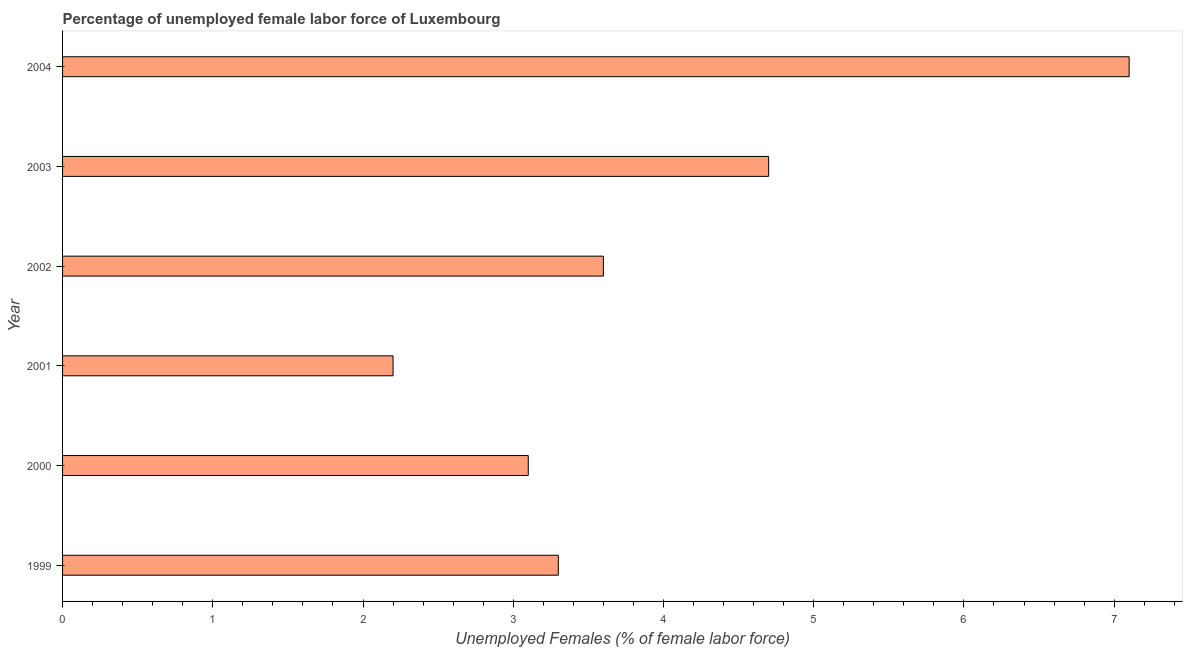Does the graph contain any zero values?
Provide a succinct answer. No. Does the graph contain grids?
Your response must be concise. No. What is the title of the graph?
Your answer should be very brief. Percentage of unemployed female labor force of Luxembourg. What is the label or title of the X-axis?
Provide a short and direct response. Unemployed Females (% of female labor force). What is the label or title of the Y-axis?
Provide a short and direct response. Year. What is the total unemployed female labour force in 1999?
Provide a succinct answer. 3.3. Across all years, what is the maximum total unemployed female labour force?
Offer a terse response. 7.1. Across all years, what is the minimum total unemployed female labour force?
Your answer should be very brief. 2.2. In which year was the total unemployed female labour force maximum?
Provide a succinct answer. 2004. What is the sum of the total unemployed female labour force?
Provide a short and direct response. 24. What is the difference between the total unemployed female labour force in 2001 and 2004?
Make the answer very short. -4.9. What is the average total unemployed female labour force per year?
Provide a short and direct response. 4. What is the median total unemployed female labour force?
Make the answer very short. 3.45. In how many years, is the total unemployed female labour force greater than 2.6 %?
Keep it short and to the point. 5. What is the ratio of the total unemployed female labour force in 2001 to that in 2004?
Offer a very short reply. 0.31. Is the total unemployed female labour force in 2001 less than that in 2004?
Provide a succinct answer. Yes. Is the difference between the total unemployed female labour force in 1999 and 2003 greater than the difference between any two years?
Your answer should be compact. No. Is the sum of the total unemployed female labour force in 2002 and 2003 greater than the maximum total unemployed female labour force across all years?
Your response must be concise. Yes. Are all the bars in the graph horizontal?
Provide a short and direct response. Yes. What is the Unemployed Females (% of female labor force) of 1999?
Offer a very short reply. 3.3. What is the Unemployed Females (% of female labor force) in 2000?
Your answer should be compact. 3.1. What is the Unemployed Females (% of female labor force) of 2001?
Your response must be concise. 2.2. What is the Unemployed Females (% of female labor force) in 2002?
Provide a succinct answer. 3.6. What is the Unemployed Females (% of female labor force) of 2003?
Offer a very short reply. 4.7. What is the Unemployed Females (% of female labor force) of 2004?
Provide a succinct answer. 7.1. What is the difference between the Unemployed Females (% of female labor force) in 1999 and 2001?
Your answer should be compact. 1.1. What is the difference between the Unemployed Females (% of female labor force) in 1999 and 2002?
Your answer should be very brief. -0.3. What is the difference between the Unemployed Females (% of female labor force) in 1999 and 2003?
Keep it short and to the point. -1.4. What is the difference between the Unemployed Females (% of female labor force) in 2000 and 2001?
Your answer should be compact. 0.9. What is the difference between the Unemployed Females (% of female labor force) in 2000 and 2002?
Your response must be concise. -0.5. What is the difference between the Unemployed Females (% of female labor force) in 2000 and 2003?
Your answer should be compact. -1.6. What is the difference between the Unemployed Females (% of female labor force) in 2000 and 2004?
Ensure brevity in your answer.  -4. What is the ratio of the Unemployed Females (% of female labor force) in 1999 to that in 2000?
Make the answer very short. 1.06. What is the ratio of the Unemployed Females (% of female labor force) in 1999 to that in 2001?
Provide a succinct answer. 1.5. What is the ratio of the Unemployed Females (% of female labor force) in 1999 to that in 2002?
Offer a very short reply. 0.92. What is the ratio of the Unemployed Females (% of female labor force) in 1999 to that in 2003?
Provide a short and direct response. 0.7. What is the ratio of the Unemployed Females (% of female labor force) in 1999 to that in 2004?
Offer a terse response. 0.47. What is the ratio of the Unemployed Females (% of female labor force) in 2000 to that in 2001?
Provide a succinct answer. 1.41. What is the ratio of the Unemployed Females (% of female labor force) in 2000 to that in 2002?
Make the answer very short. 0.86. What is the ratio of the Unemployed Females (% of female labor force) in 2000 to that in 2003?
Give a very brief answer. 0.66. What is the ratio of the Unemployed Females (% of female labor force) in 2000 to that in 2004?
Offer a terse response. 0.44. What is the ratio of the Unemployed Females (% of female labor force) in 2001 to that in 2002?
Ensure brevity in your answer.  0.61. What is the ratio of the Unemployed Females (% of female labor force) in 2001 to that in 2003?
Make the answer very short. 0.47. What is the ratio of the Unemployed Females (% of female labor force) in 2001 to that in 2004?
Keep it short and to the point. 0.31. What is the ratio of the Unemployed Females (% of female labor force) in 2002 to that in 2003?
Your response must be concise. 0.77. What is the ratio of the Unemployed Females (% of female labor force) in 2002 to that in 2004?
Make the answer very short. 0.51. What is the ratio of the Unemployed Females (% of female labor force) in 2003 to that in 2004?
Your answer should be very brief. 0.66. 